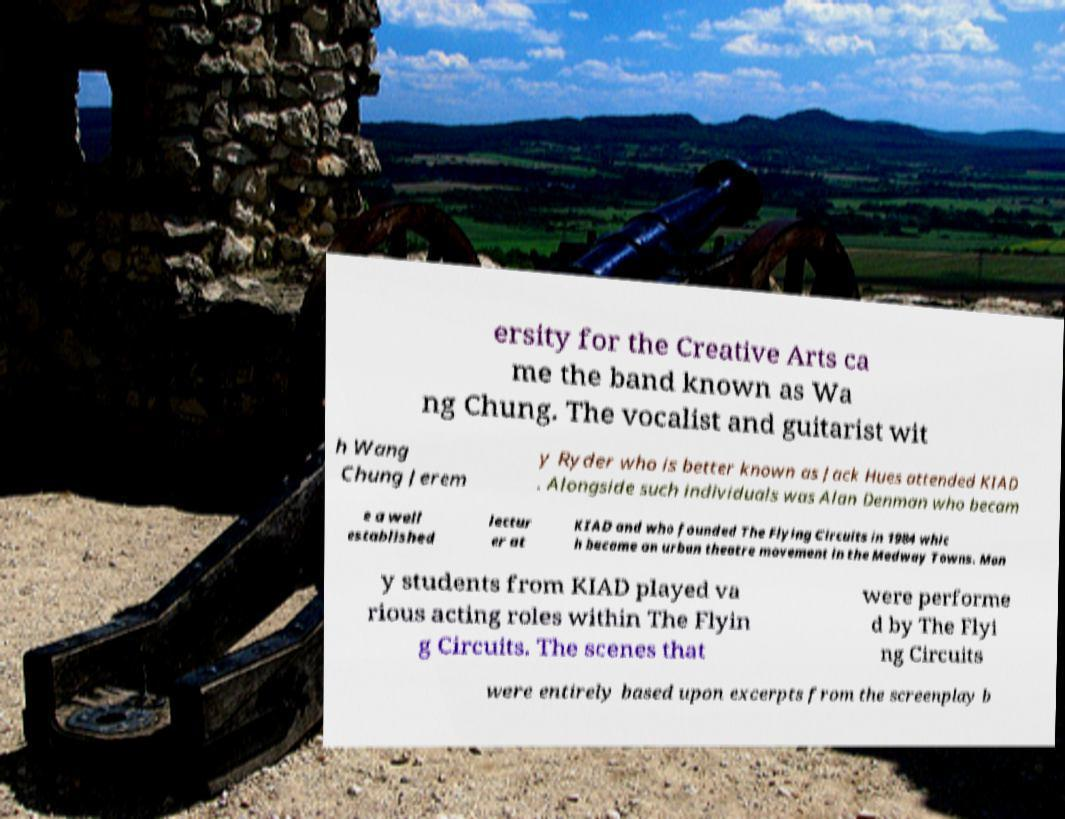I need the written content from this picture converted into text. Can you do that? ersity for the Creative Arts ca me the band known as Wa ng Chung. The vocalist and guitarist wit h Wang Chung Jerem y Ryder who is better known as Jack Hues attended KIAD . Alongside such individuals was Alan Denman who becam e a well established lectur er at KIAD and who founded The Flying Circuits in 1984 whic h became an urban theatre movement in the Medway Towns. Man y students from KIAD played va rious acting roles within The Flyin g Circuits. The scenes that were performe d by The Flyi ng Circuits were entirely based upon excerpts from the screenplay b 